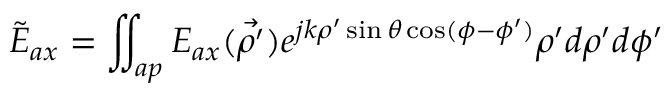Convert formula to latex. <formula><loc_0><loc_0><loc_500><loc_500>\tilde { E } _ { a x } = \iint _ { a p } E _ { a x } ( \vec { \rho ^ { \prime } } ) e ^ { j k \rho ^ { \prime } \sin \theta \cos ( \phi - \phi ^ { \prime } ) } \rho ^ { \prime } d \rho ^ { \prime } d \phi ^ { \prime }</formula> 